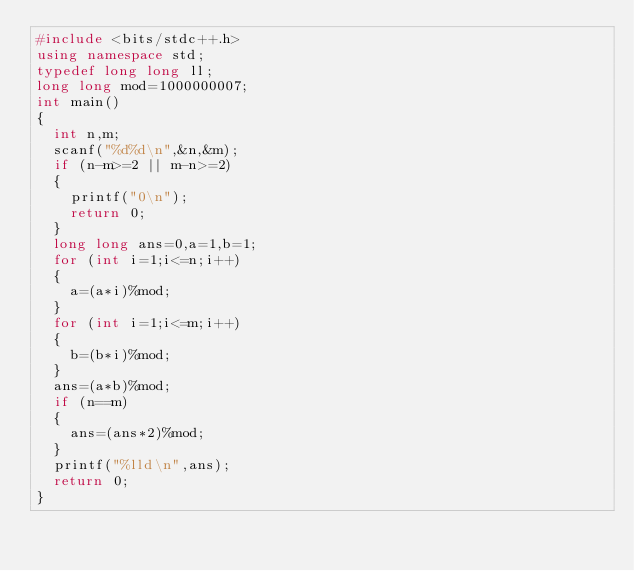<code> <loc_0><loc_0><loc_500><loc_500><_C++_>#include <bits/stdc++.h>
using namespace std;
typedef long long ll;
long long mod=1000000007;
int main()
{
	int n,m;
	scanf("%d%d\n",&n,&m);
	if (n-m>=2 || m-n>=2)
	{
		printf("0\n");
		return 0;
	} 
	long long ans=0,a=1,b=1;
	for (int i=1;i<=n;i++)
	{
		a=(a*i)%mod;
	}
	for (int i=1;i<=m;i++)
	{
		b=(b*i)%mod;
	}
	ans=(a*b)%mod;
	if (n==m)
	{
		ans=(ans*2)%mod;
	}
	printf("%lld\n",ans);
	return 0;
}</code> 